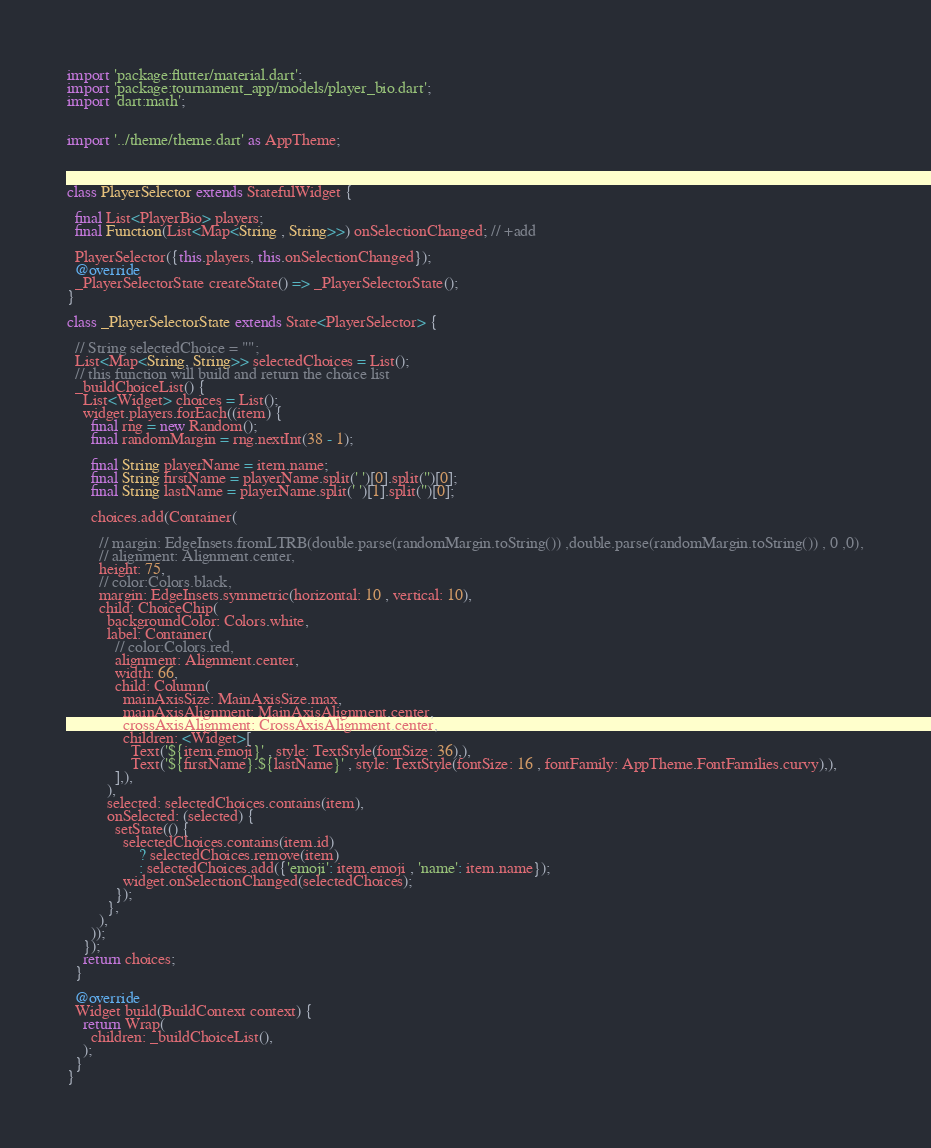<code> <loc_0><loc_0><loc_500><loc_500><_Dart_>import 'package:flutter/material.dart';
import 'package:tournament_app/models/player_bio.dart';
import 'dart:math';


import '../theme/theme.dart' as AppTheme;



class PlayerSelector extends StatefulWidget {

  final List<PlayerBio> players;
  final Function(List<Map<String , String>>) onSelectionChanged; // +add

  PlayerSelector({this.players, this.onSelectionChanged});
  @override
  _PlayerSelectorState createState() => _PlayerSelectorState();
}

class _PlayerSelectorState extends State<PlayerSelector> {
  
  // String selectedChoice = "";
  List<Map<String, String>> selectedChoices = List();
  // this function will build and return the choice list
  _buildChoiceList() {
    List<Widget> choices = List();
    widget.players.forEach((item) {
      final rng = new Random();
      final randomMargin = rng.nextInt(38 - 1);

      final String playerName = item.name;
      final String firstName = playerName.split(' ')[0].split('')[0];
      final String lastName = playerName.split(' ')[1].split('')[0];

      choices.add(Container(

        // margin: EdgeInsets.fromLTRB(double.parse(randomMargin.toString()) ,double.parse(randomMargin.toString()) , 0 ,0),
        // alignment: Alignment.center,
        height: 75,
        // color:Colors.black,
        margin: EdgeInsets.symmetric(horizontal: 10 , vertical: 10),
        child: ChoiceChip(
          backgroundColor: Colors.white,
          label: Container(
            // color:Colors.red,
            alignment: Alignment.center,
            width: 66,
            child: Column(
              mainAxisSize: MainAxisSize.max,
              mainAxisAlignment: MainAxisAlignment.center,
              crossAxisAlignment: CrossAxisAlignment.center,
              children: <Widget>[
                Text('${item.emoji}' , style: TextStyle(fontSize: 36),),
                Text('${firstName}.${lastName}' , style: TextStyle(fontSize: 16 , fontFamily: AppTheme.FontFamilies.curvy),),
            ],),
          ),
          selected: selectedChoices.contains(item),
          onSelected: (selected) {
            setState(() {
              selectedChoices.contains(item.id)
                  ? selectedChoices.remove(item)
                  : selectedChoices.add({'emoji': item.emoji , 'name': item.name});
              widget.onSelectionChanged(selectedChoices);
            });
          },
        ),
      ));
    });
    return choices;
  }

  @override
  Widget build(BuildContext context) {
    return Wrap(
      children: _buildChoiceList(),
    );
  }
}
</code> 